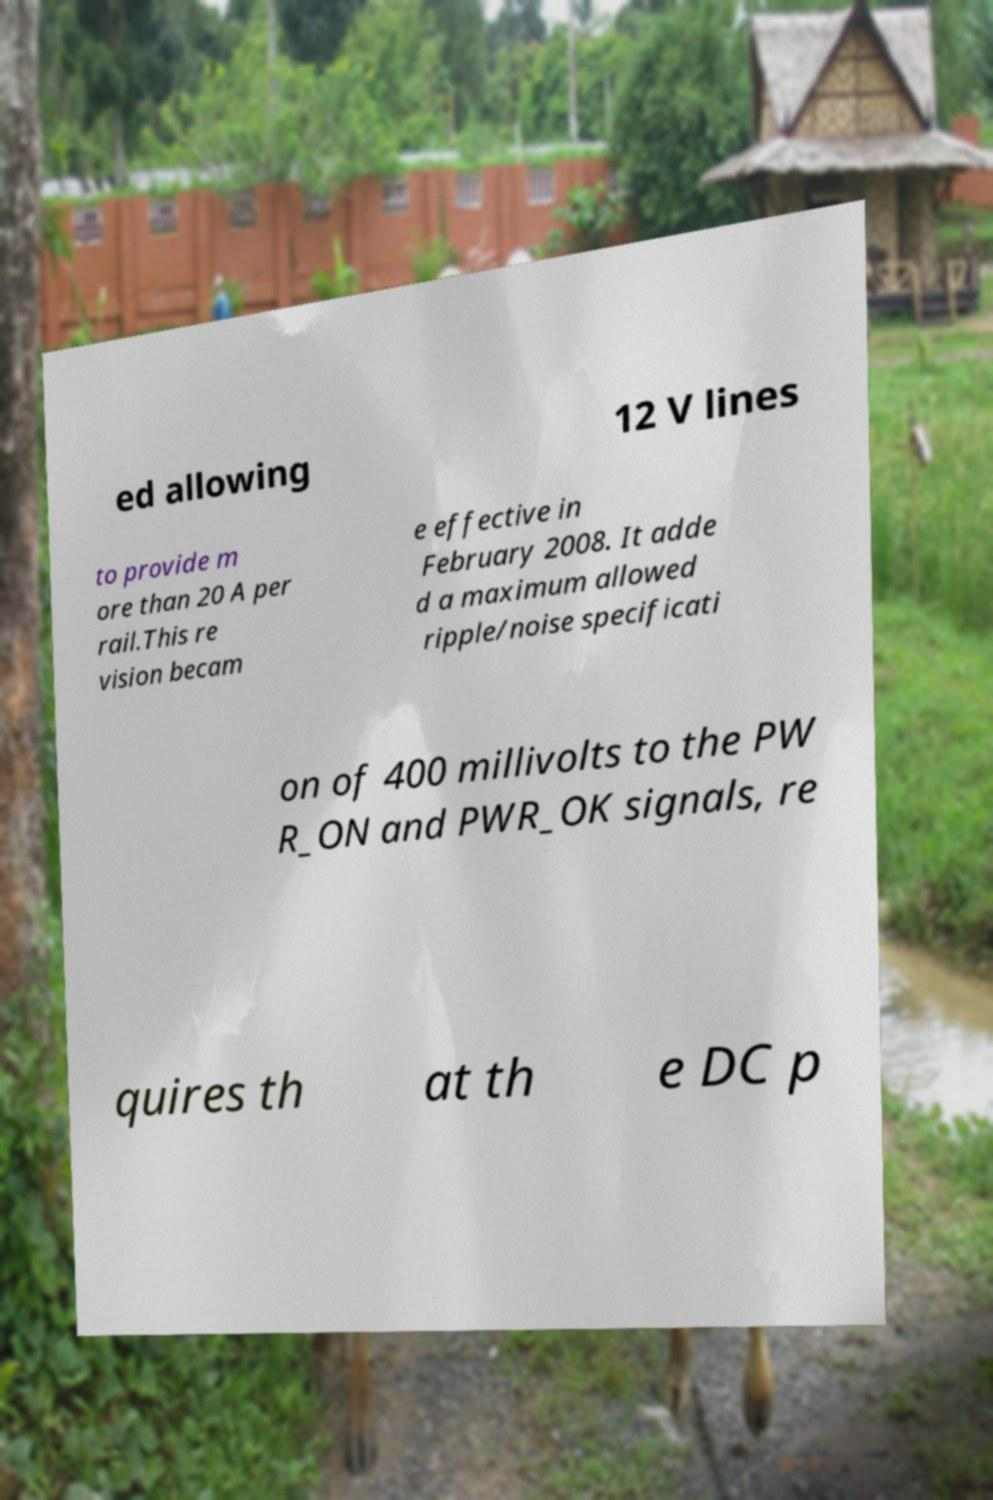What messages or text are displayed in this image? I need them in a readable, typed format. ed allowing 12 V lines to provide m ore than 20 A per rail.This re vision becam e effective in February 2008. It adde d a maximum allowed ripple/noise specificati on of 400 millivolts to the PW R_ON and PWR_OK signals, re quires th at th e DC p 